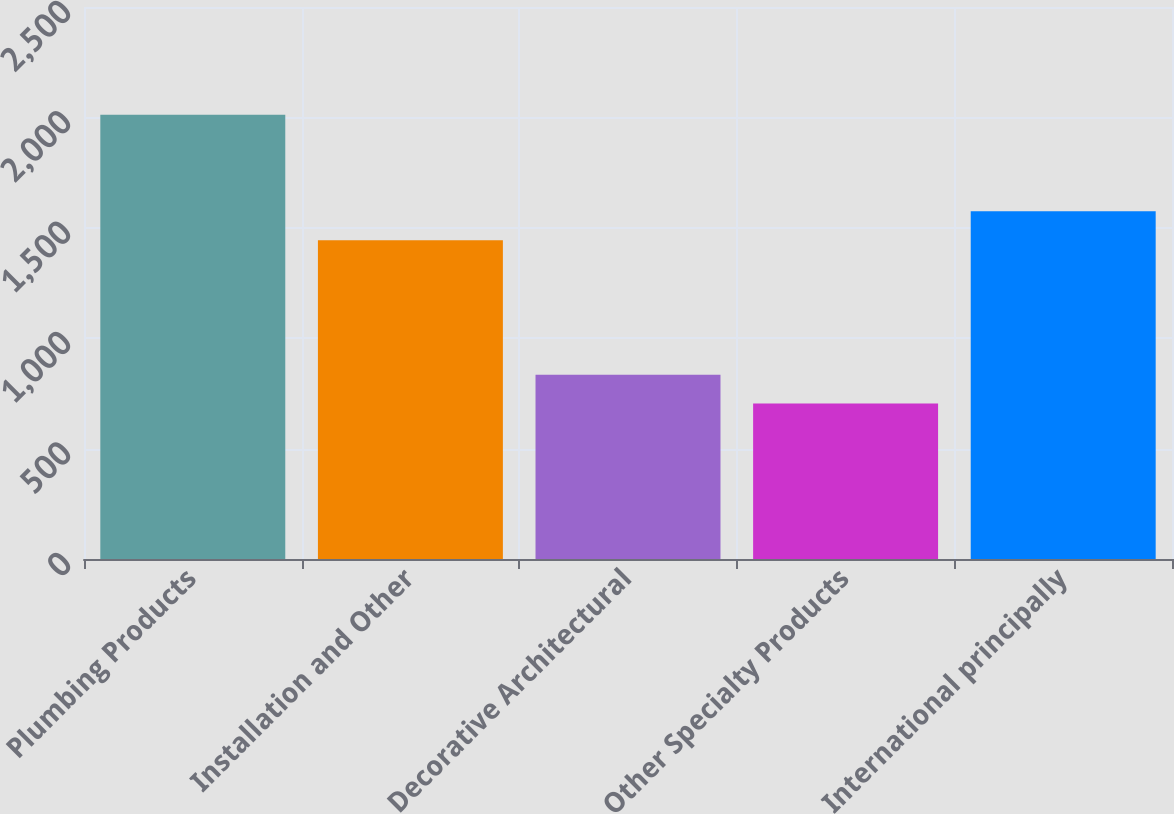Convert chart. <chart><loc_0><loc_0><loc_500><loc_500><bar_chart><fcel>Plumbing Products<fcel>Installation and Other<fcel>Decorative Architectural<fcel>Other Specialty Products<fcel>International principally<nl><fcel>2012<fcel>1444<fcel>834.8<fcel>704<fcel>1574.8<nl></chart> 